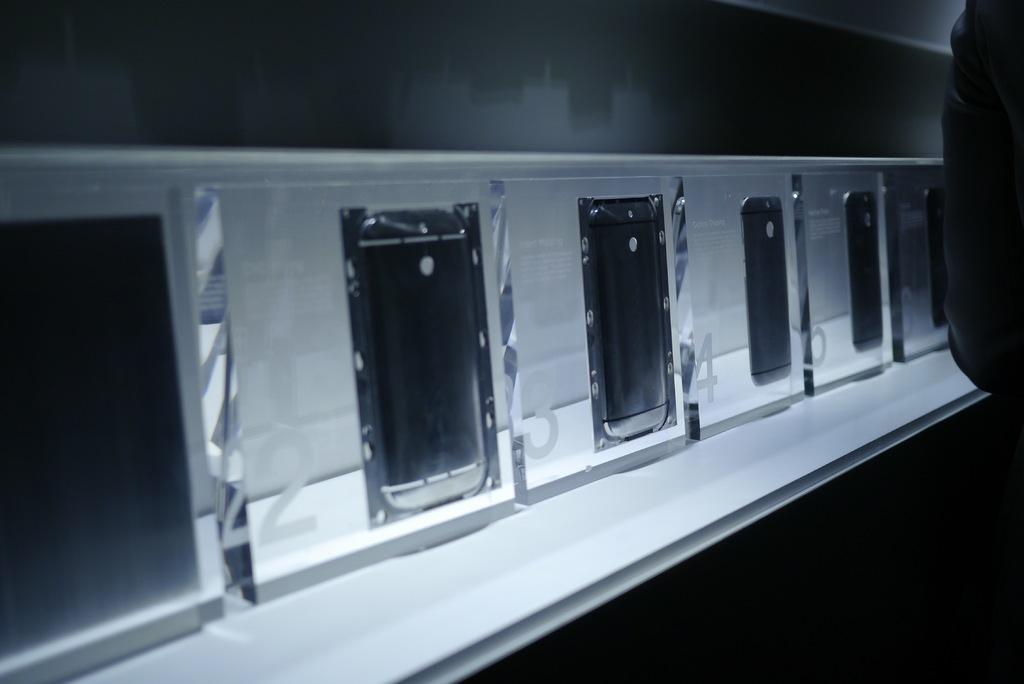What is the number on the left?
Ensure brevity in your answer.  2. What is the last number?
Make the answer very short. 6. 